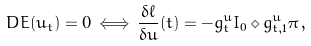<formula> <loc_0><loc_0><loc_500><loc_500>D E ( u _ { t } ) = 0 \, \Longleftrightarrow \, \frac { \delta \ell } { \delta u } ( t ) = - g ^ { u } _ { t } I _ { 0 } \diamond g ^ { u } _ { t , 1 } \pi \, ,</formula> 